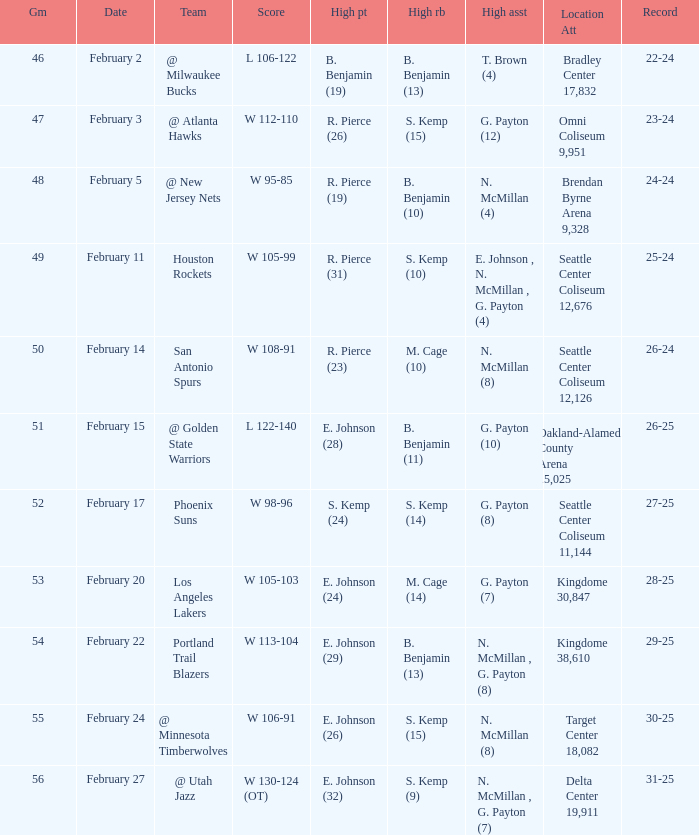Which game had a score of w 95-85? 48.0. 